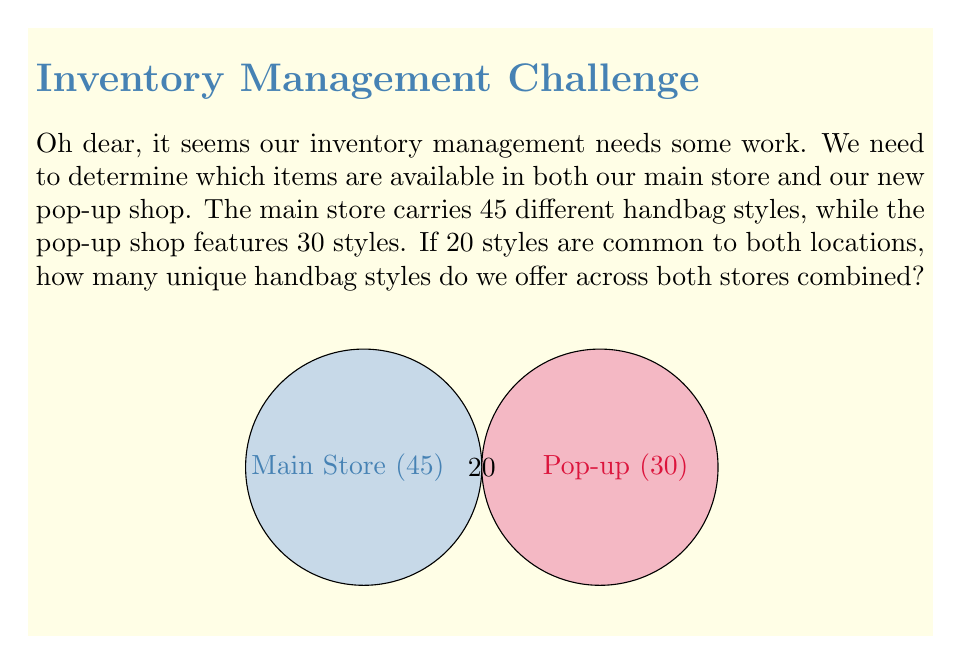Show me your answer to this math problem. Let's approach this step-by-step using set theory:

1) Let $A$ be the set of handbag styles in the main store, and $B$ be the set of styles in the pop-up shop.

2) We're given:
   $|A| = 45$ (cardinality of set A)
   $|B| = 30$ (cardinality of set B)
   $|A \cap B| = 20$ (cardinality of the intersection of A and B)

3) We need to find the number of unique styles across both stores, which is the union of sets A and B, denoted as $|A \cup B|$.

4) We can use the formula for the cardinality of a union:
   $|A \cup B| = |A| + |B| - |A \cap B|$

5) Substituting the values:
   $|A \cup B| = 45 + 30 - 20$

6) Calculating:
   $|A \cup B| = 75 - 20 = 55$

Therefore, we offer 55 unique handbag styles across both stores combined.
Answer: 55 unique handbag styles 